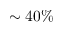Convert formula to latex. <formula><loc_0><loc_0><loc_500><loc_500>\sim 4 0 \%</formula> 